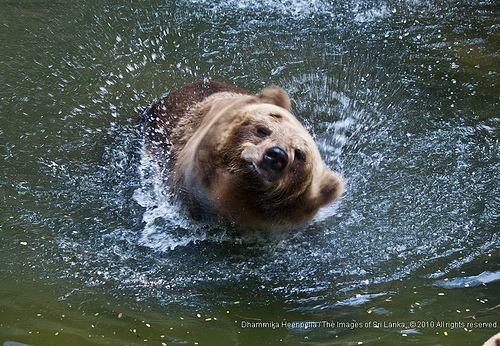<image>
Is there a bear in the water? Yes. The bear is contained within or inside the water, showing a containment relationship. 